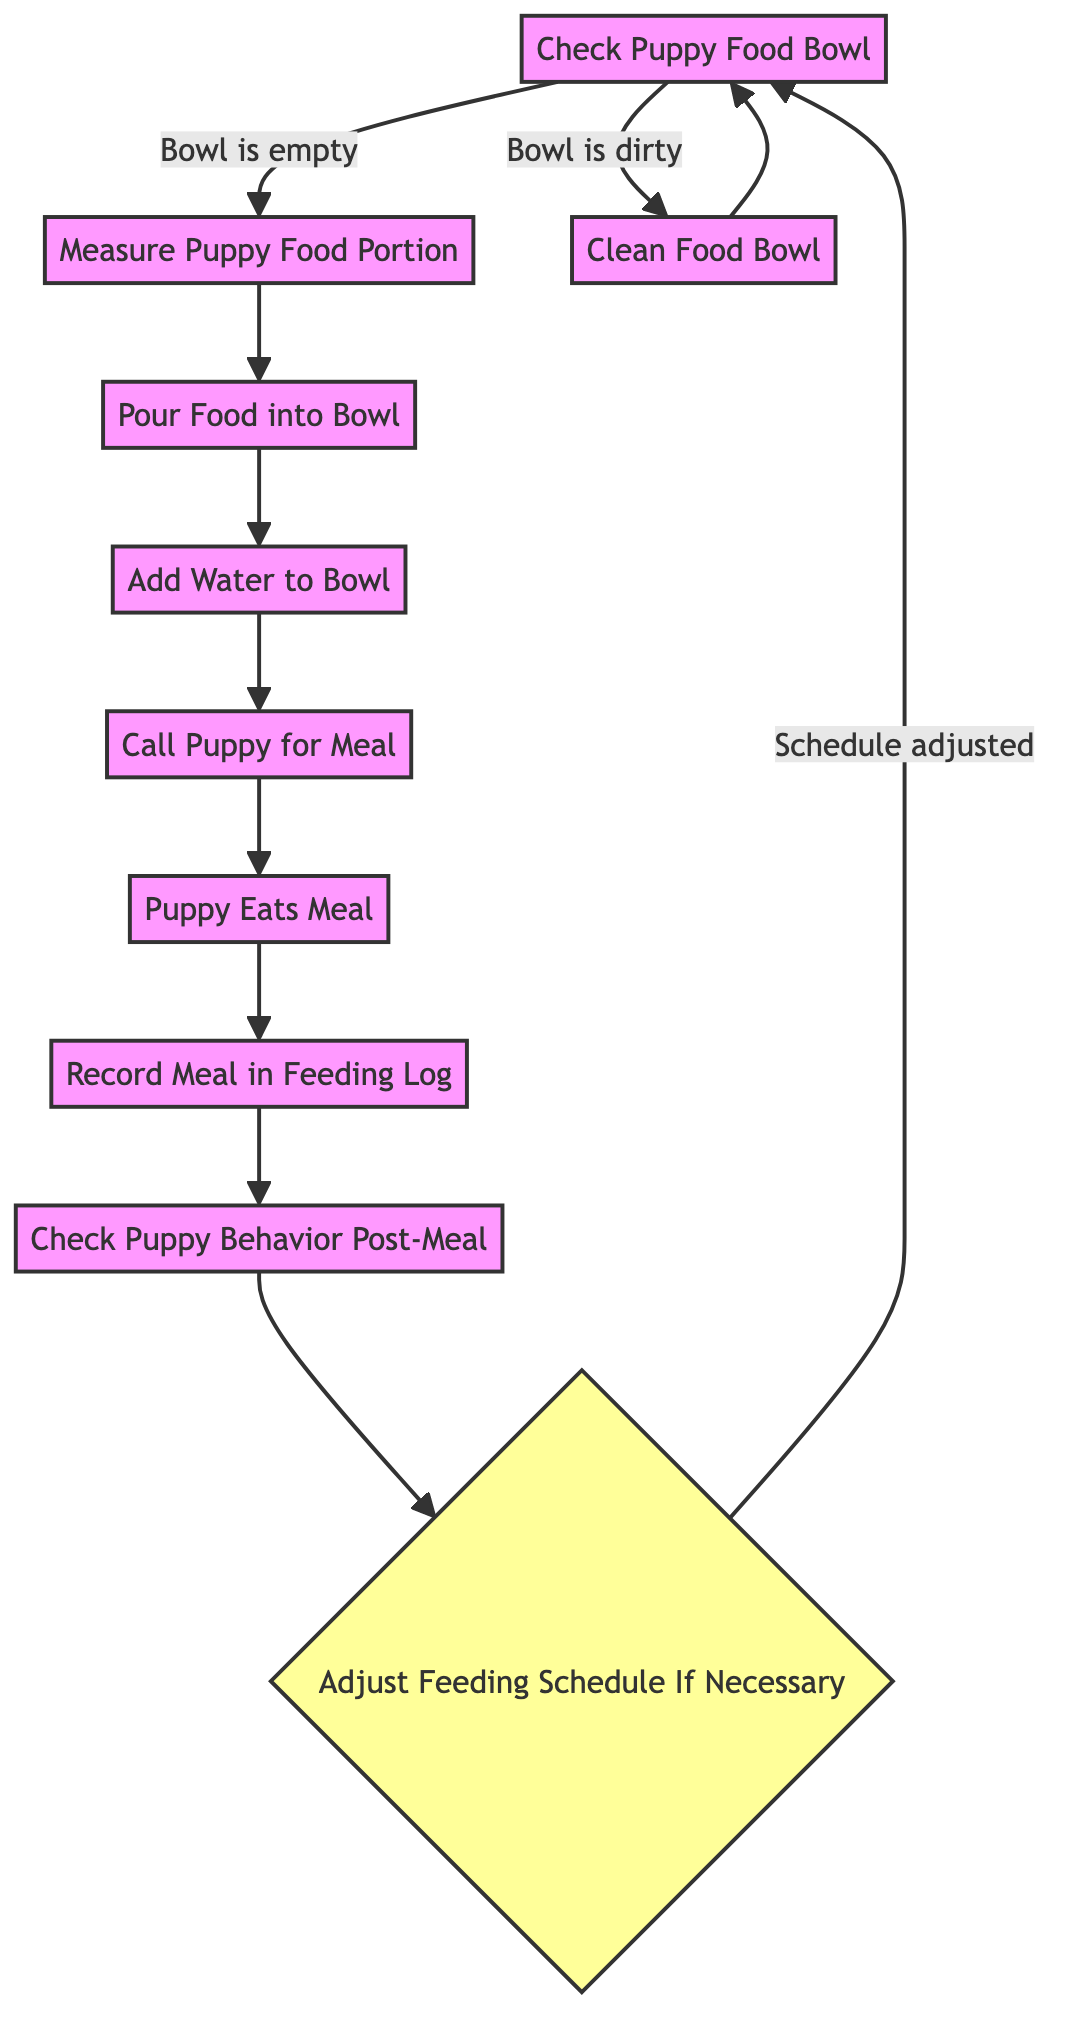What is the starting activity in the diagram? The starting activity is indicated at the beginning of the flow and is labeled "Check Puppy Food Bowl."
Answer: Check Puppy Food Bowl How many decision points are present in the diagram? Counting the nodes labeled as decision points, there is one decision point, which is "Adjust Feeding Schedule If Necessary."
Answer: 1 What happens if the puppy food bowl is dirty? If the puppy food bowl is dirty, the flow transitions to the "Clean Food Bowl" activity. This connection is directly indicated in the diagram.
Answer: Clean Food Bowl What activity follows after "Puppy Eats Meal"? Following the "Puppy Eats Meal," the next activity indicated is "Record Meal in Feeding Log." This connection is outlined in the flow from one action to the next.
Answer: Record Meal in Feeding Log If the bowl is empty, what is the next action? When the bowl is empty, the transition proceeds to "Measure Puppy Food Portion," as denoted in the diagram with the condition specified.
Answer: Measure Puppy Food Portion What do you do after recording the meal in the feeding log? After recording the meal in the feeding log, the next step is to "Check Puppy Behavior Post-Meal," continuing the sequence in the diagram.
Answer: Check Puppy Behavior Post-Meal Which two activities can follow after "Check Puppy Food Bowl"? The activities that can follow "Check Puppy Food Bowl" depend on its condition: either "Measure Puppy Food Portion" if it is empty or "Clean Food Bowl" if it is dirty.
Answer: Measure Puppy Food Portion, Clean Food Bowl What condition leads to adjusting the feeding schedule? The condition "Schedule adjusted" determines whether to return to "Check Puppy Food Bowl" after evaluating the puppy's behavior. This relationship is part of the feedback loop shown in the diagram.
Answer: Schedule adjusted 